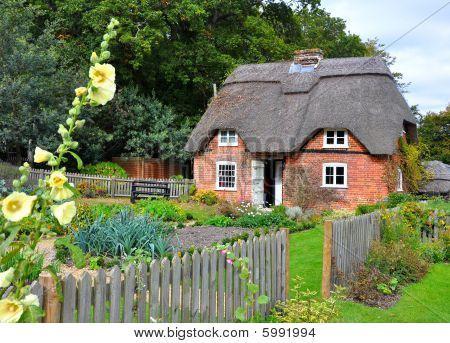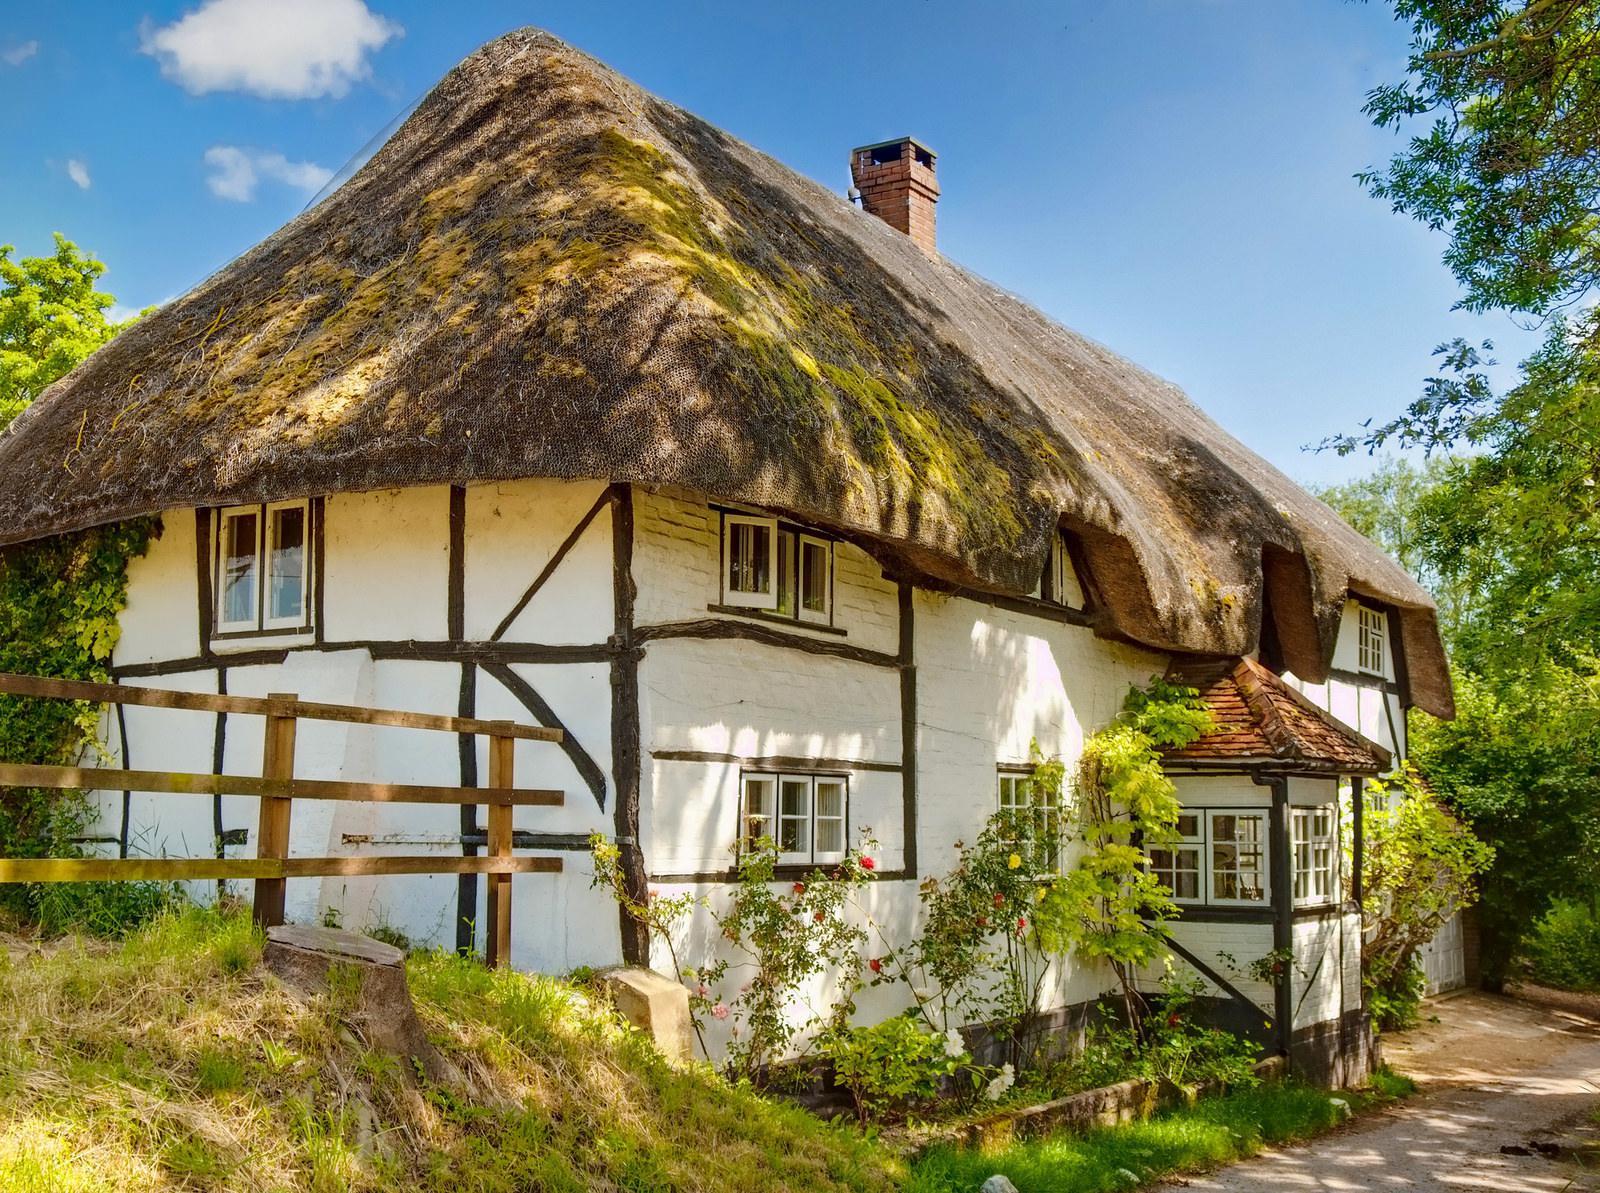The first image is the image on the left, the second image is the image on the right. Considering the images on both sides, is "Each house shows only one chimney" valid? Answer yes or no. Yes. The first image is the image on the left, the second image is the image on the right. Assess this claim about the two images: "In at least one image there is a white house with black strip trim.". Correct or not? Answer yes or no. Yes. 